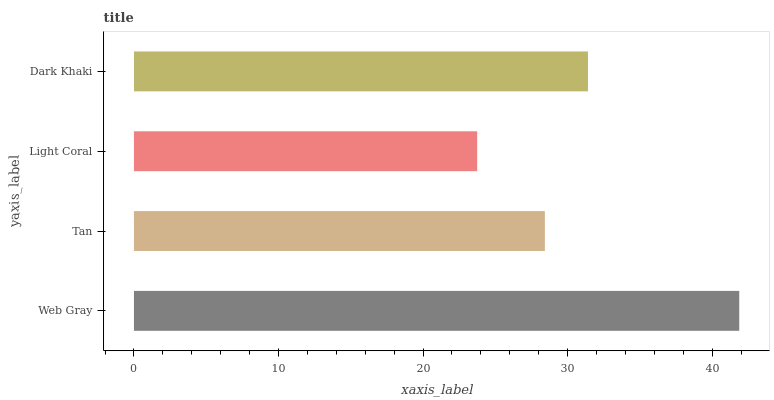Is Light Coral the minimum?
Answer yes or no. Yes. Is Web Gray the maximum?
Answer yes or no. Yes. Is Tan the minimum?
Answer yes or no. No. Is Tan the maximum?
Answer yes or no. No. Is Web Gray greater than Tan?
Answer yes or no. Yes. Is Tan less than Web Gray?
Answer yes or no. Yes. Is Tan greater than Web Gray?
Answer yes or no. No. Is Web Gray less than Tan?
Answer yes or no. No. Is Dark Khaki the high median?
Answer yes or no. Yes. Is Tan the low median?
Answer yes or no. Yes. Is Tan the high median?
Answer yes or no. No. Is Web Gray the low median?
Answer yes or no. No. 